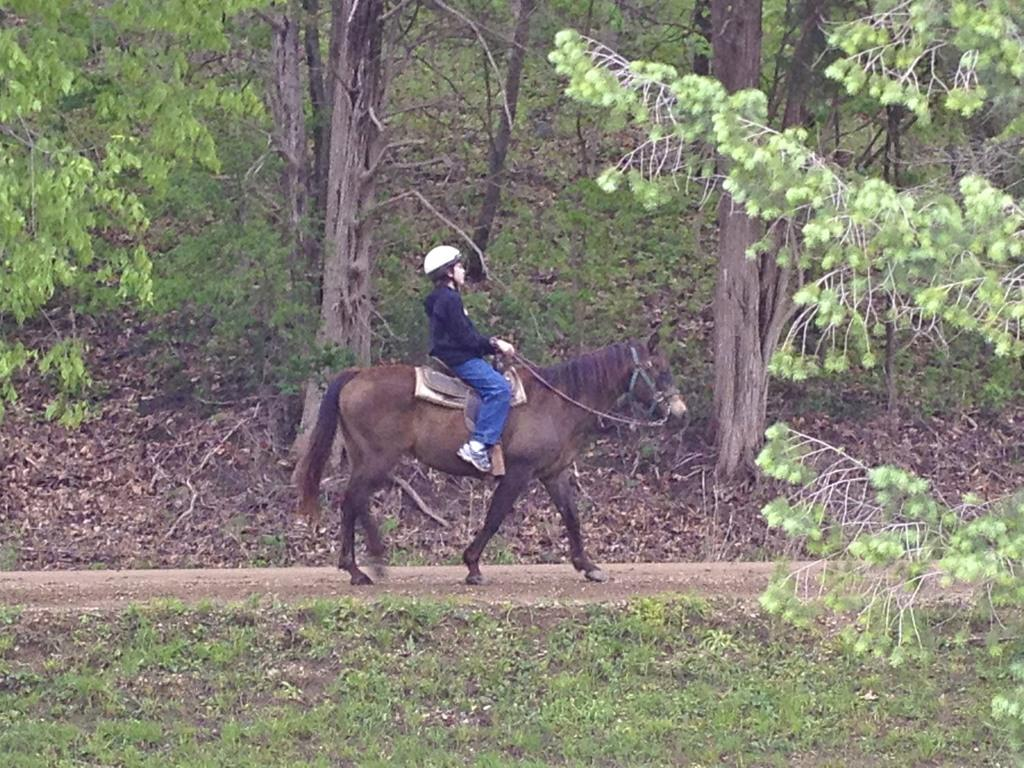What type of vegetation is present in the image? There is grass in the image. What activity is the person in the image engaged in? The person is sitting on a horse in the image. What other natural elements can be seen in the image? There are trees in the image. What might be used for walking or traveling in the image? There is a path visible in the image. Where is the monkey sitting on the pan in the image? There is no monkey or pan present in the image. What type of things are being carried by the person on the horse in the image? The image does not show any things being carried by the person on the horse. 